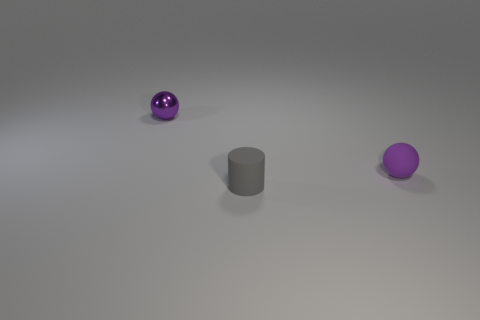Add 2 big matte spheres. How many objects exist? 5 Subtract all spheres. How many objects are left? 1 Subtract 0 blue cubes. How many objects are left? 3 Subtract all small purple things. Subtract all rubber cylinders. How many objects are left? 0 Add 2 small gray matte objects. How many small gray matte objects are left? 3 Add 2 tiny matte spheres. How many tiny matte spheres exist? 3 